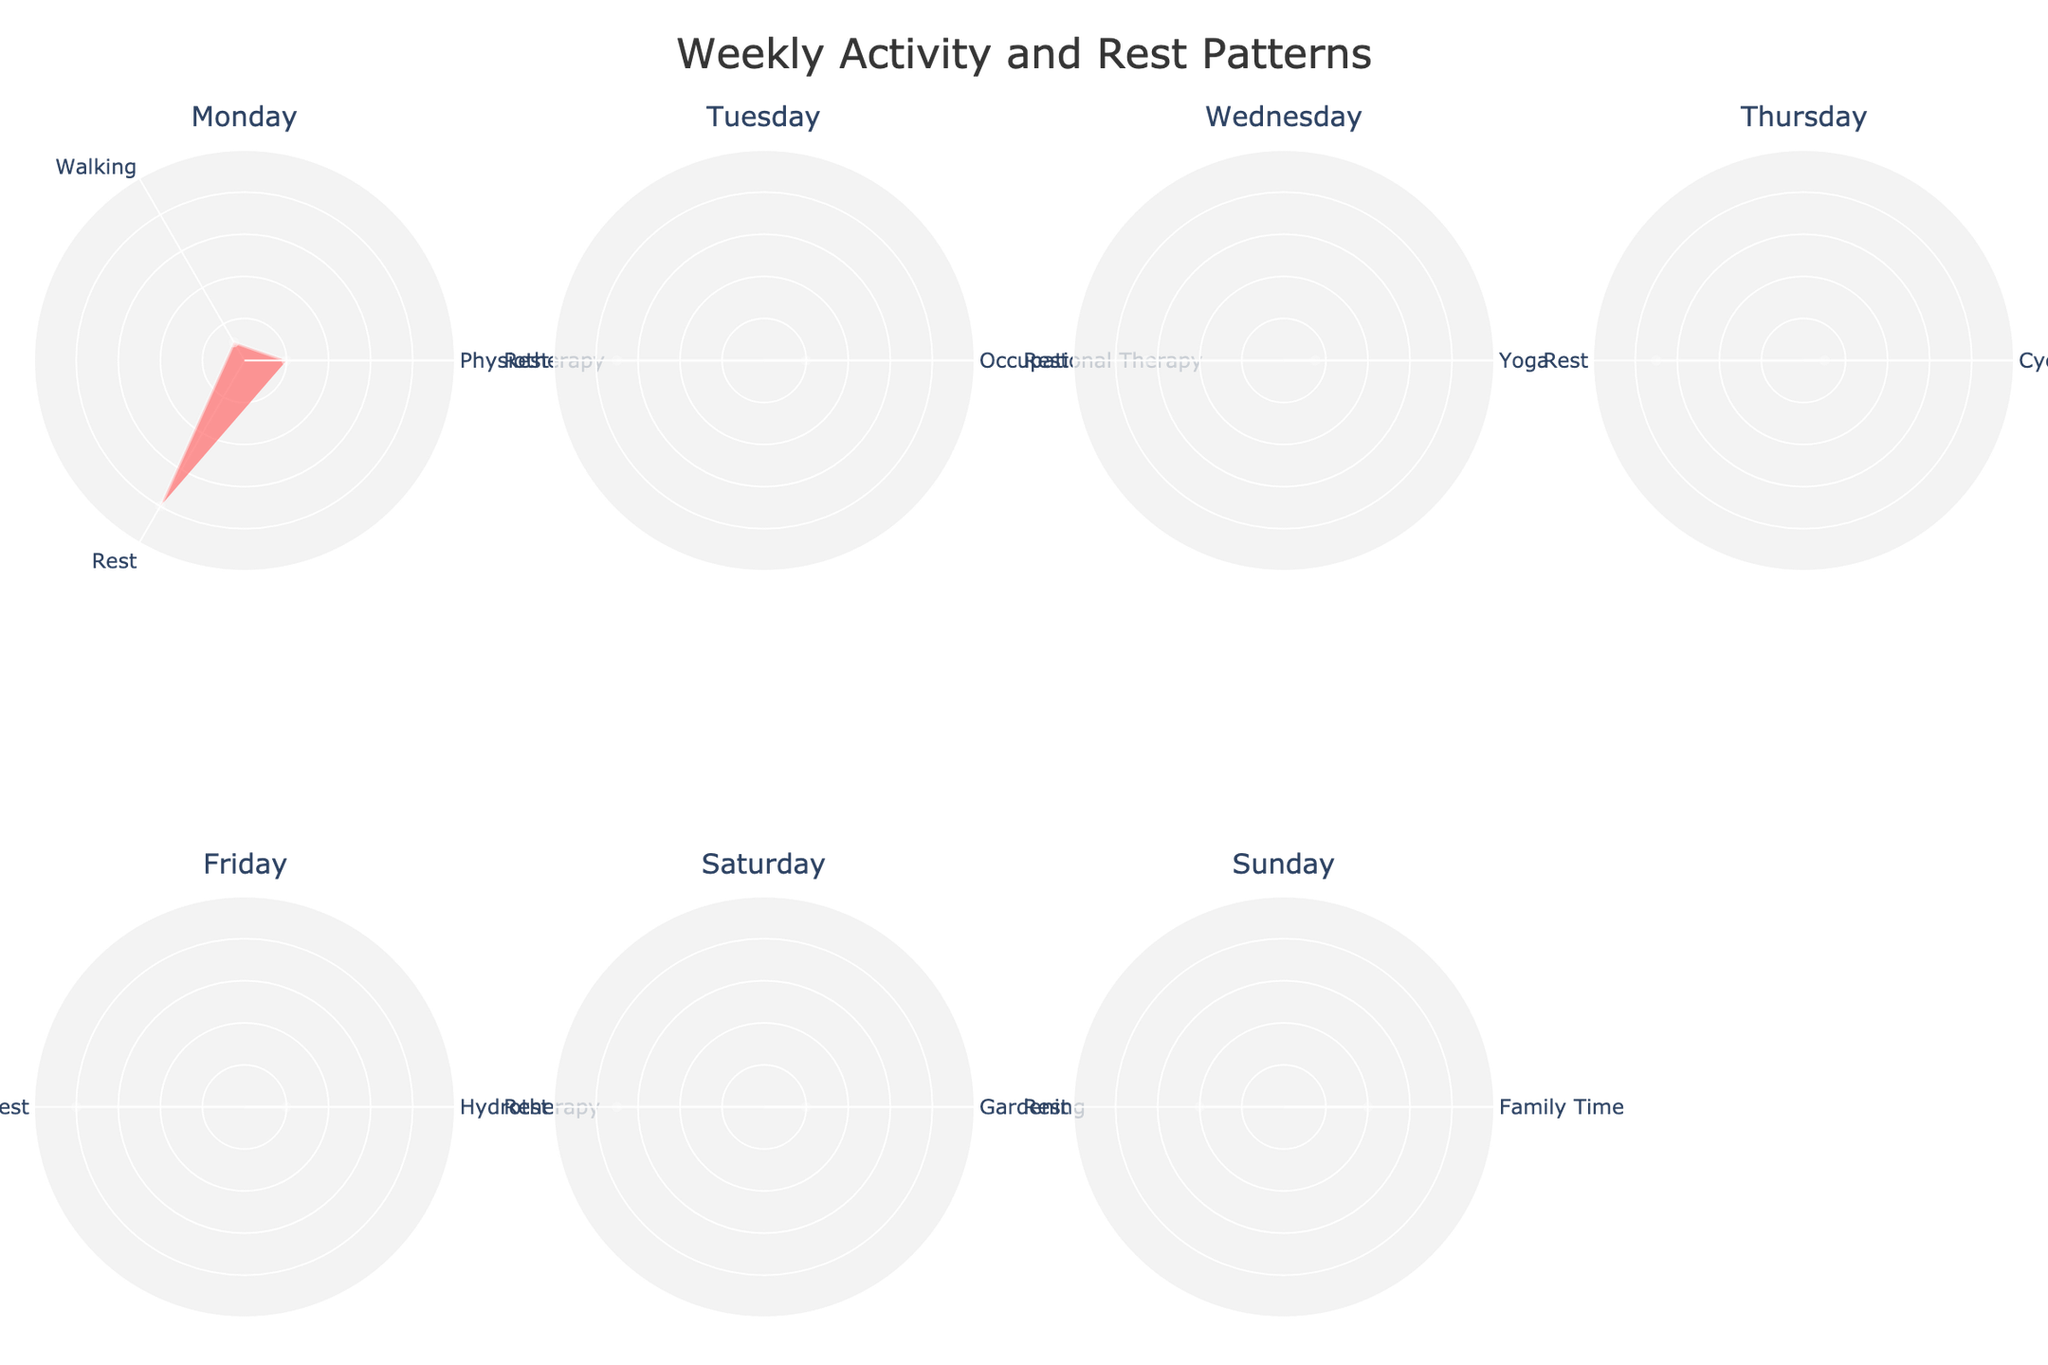What is the title of the figure? The title is typically located at the top of the figure. It provides a brief summary of the visualized data.
Answer: Weekly Activity and Rest Patterns How many days of the week are represented in the subplots? Count the number of subplot titles which correspond to days of the week.
Answer: 7 What activities are present on Sunday? Look at the polar chart specific to Sunday and read the labels around the circle.
Answer: Family Time and Rest Which day has the longest single activity duration? Identify the slice with the largest radius in each subplot and compare them across all days.
Answer: Sunday How much total rest is accumulated over the week? Sum the 'Rest' durations for each day as shown in the polar charts: 4 + 3.5 + 3.25 + 3.5 + 4 + 3.5 + 2 = 23.75
Answer: 23.75 hours Compare the duration of physiotherapy on Monday to hydrotherapy on Friday. Which is longer? Look at the radii for 'Physiotherapy' on Monday and 'Hydrotherapy' on Friday, then compare their lengths.
Answer: Both are 1 hour Which day has the most diverse set of activities (i.e., the largest number of different types of activities)? Count the number of unique activity labels in each subplot.
Answer: Wednesday On which day is rest less than 3 hours? Check each subplot for values less than 3 hours under 'Rest'.
Answer: Sunday What is the average duration of activities (excluding rest) on Tuesday? There is one activity on Tuesday which is 'Occupational Therapy'. Its duration is 1 hour, and since there is only one activity, the average is that same value.
Answer: 1 hour 